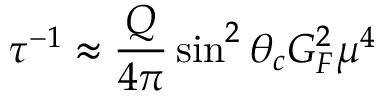Convert formula to latex. <formula><loc_0><loc_0><loc_500><loc_500>\tau ^ { - 1 } \approx \frac { Q } { 4 \pi } \sin ^ { 2 } \theta _ { c } G _ { F } ^ { 2 } \mu ^ { 4 }</formula> 